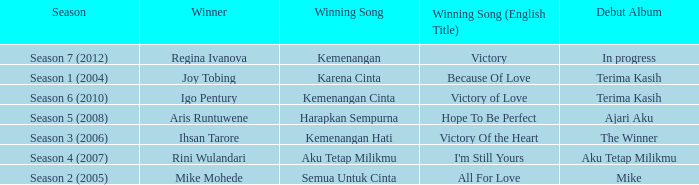Which English winning song had the winner aris runtuwene? Hope To Be Perfect. 